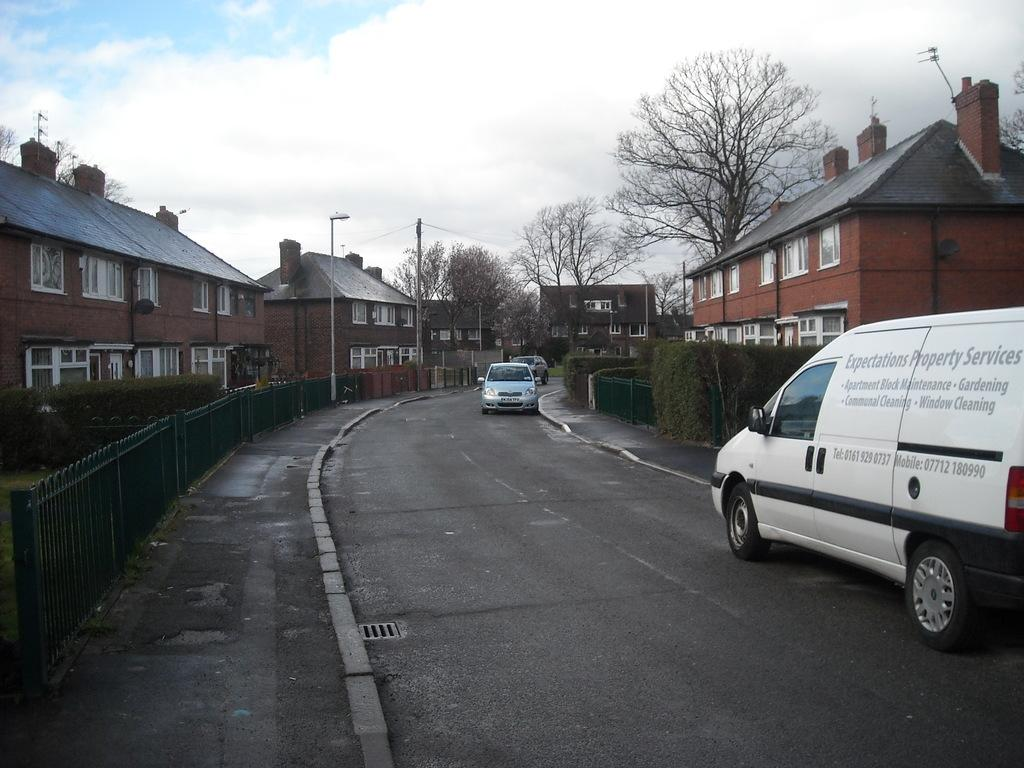<image>
Give a short and clear explanation of the subsequent image. A van from Expectations Property Services is parked on a residential street. 